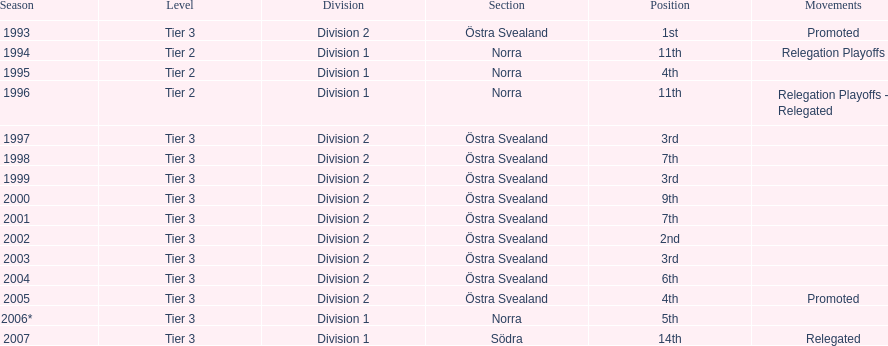Which year was more successful, 2007 or 2002? 2002. I'm looking to parse the entire table for insights. Could you assist me with that? {'header': ['Season', 'Level', 'Division', 'Section', 'Position', 'Movements'], 'rows': [['1993', 'Tier 3', 'Division 2', 'Östra Svealand', '1st', 'Promoted'], ['1994', 'Tier 2', 'Division 1', 'Norra', '11th', 'Relegation Playoffs'], ['1995', 'Tier 2', 'Division 1', 'Norra', '4th', ''], ['1996', 'Tier 2', 'Division 1', 'Norra', '11th', 'Relegation Playoffs - Relegated'], ['1997', 'Tier 3', 'Division 2', 'Östra Svealand', '3rd', ''], ['1998', 'Tier 3', 'Division 2', 'Östra Svealand', '7th', ''], ['1999', 'Tier 3', 'Division 2', 'Östra Svealand', '3rd', ''], ['2000', 'Tier 3', 'Division 2', 'Östra Svealand', '9th', ''], ['2001', 'Tier 3', 'Division 2', 'Östra Svealand', '7th', ''], ['2002', 'Tier 3', 'Division 2', 'Östra Svealand', '2nd', ''], ['2003', 'Tier 3', 'Division 2', 'Östra Svealand', '3rd', ''], ['2004', 'Tier 3', 'Division 2', 'Östra Svealand', '6th', ''], ['2005', 'Tier 3', 'Division 2', 'Östra Svealand', '4th', 'Promoted'], ['2006*', 'Tier 3', 'Division 1', 'Norra', '5th', ''], ['2007', 'Tier 3', 'Division 1', 'Södra', '14th', 'Relegated']]} 